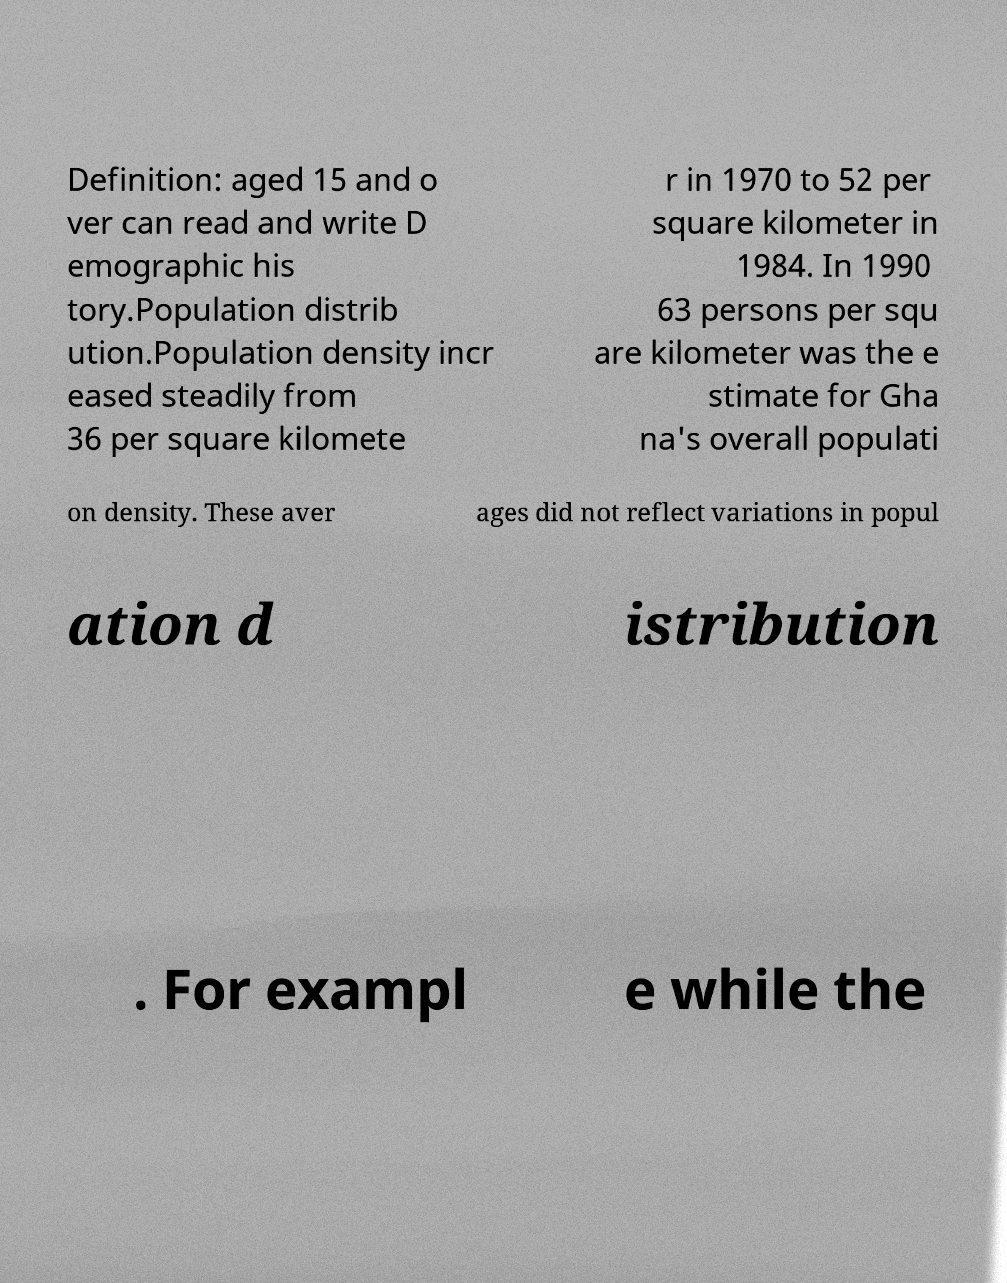What messages or text are displayed in this image? I need them in a readable, typed format. Definition: aged 15 and o ver can read and write D emographic his tory.Population distrib ution.Population density incr eased steadily from 36 per square kilomete r in 1970 to 52 per square kilometer in 1984. In 1990 63 persons per squ are kilometer was the e stimate for Gha na's overall populati on density. These aver ages did not reflect variations in popul ation d istribution . For exampl e while the 